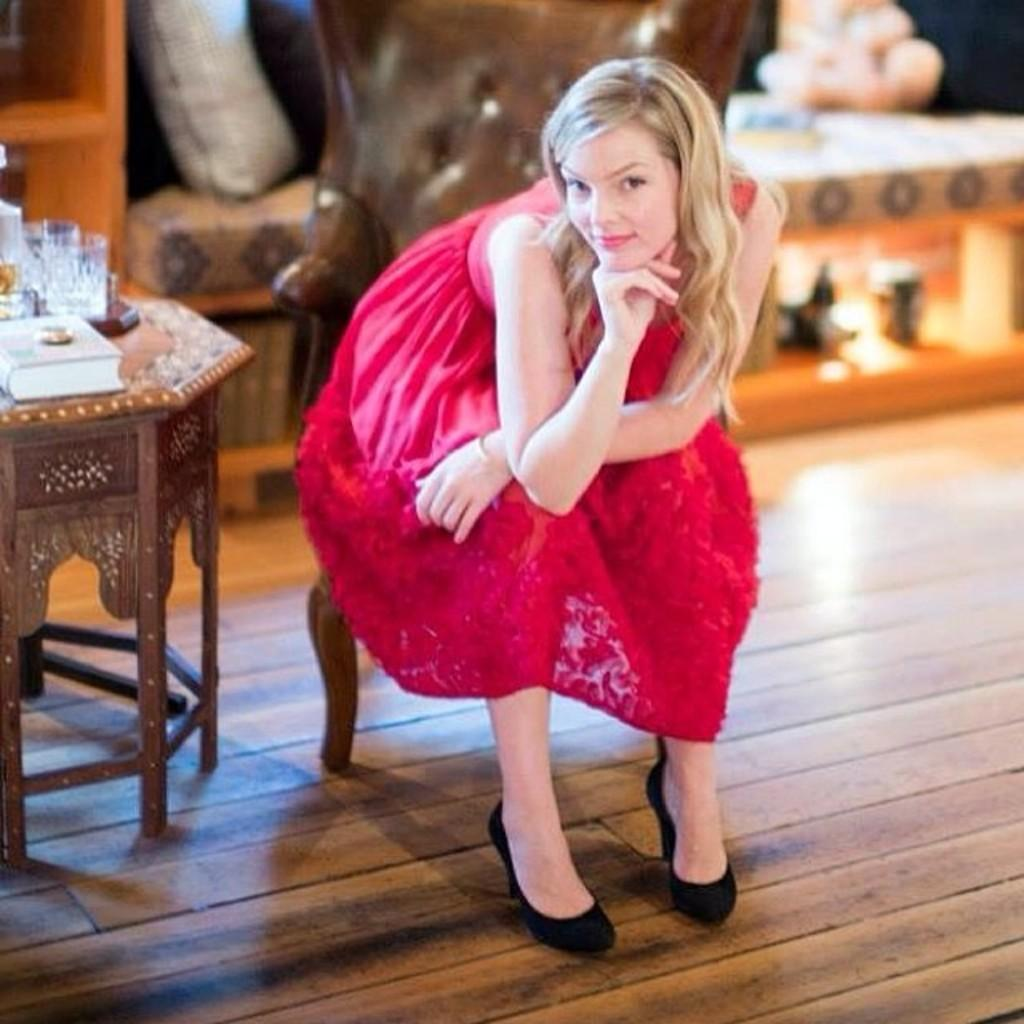Who is the main subject in the picture? There is a girl in the picture. What is the girl doing in the image? The girl is sitting on a chair. What objects are on the table in the image? There is a glass and a book on the table. What type of feather can be seen on the stage in the image? There is no stage or feather present in the image; it features a girl sitting on a chair with a glass and a book on the table. 